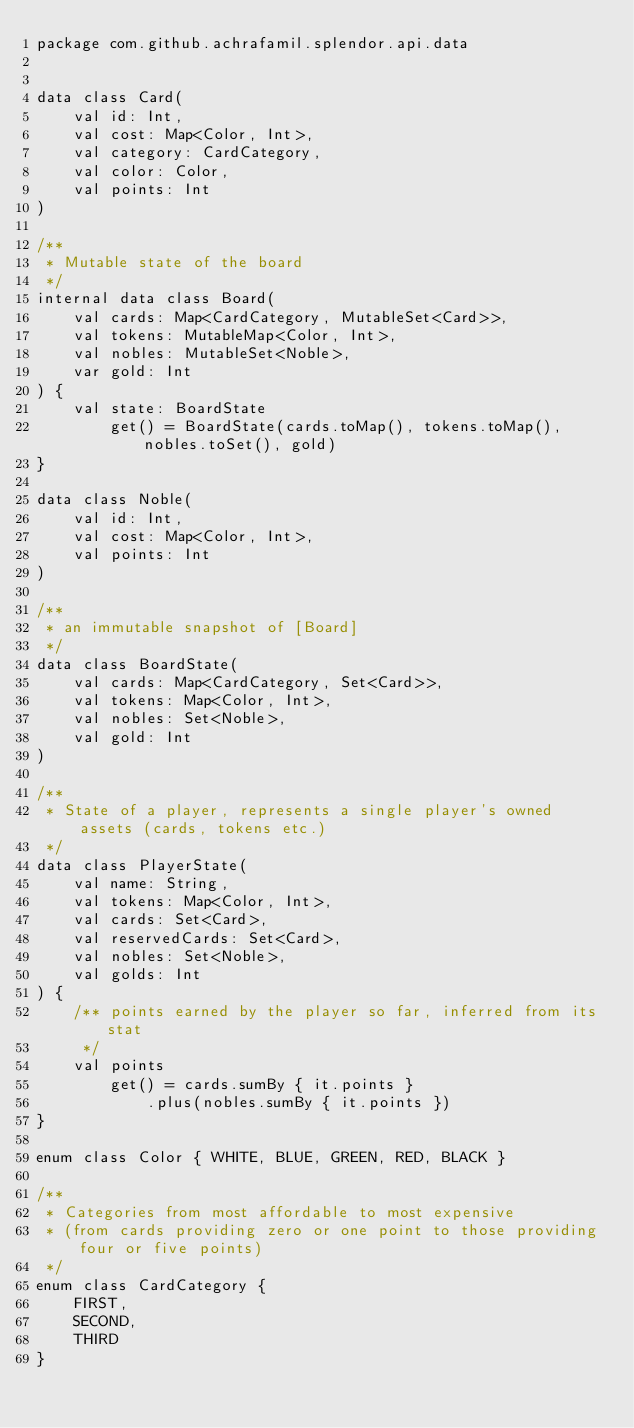Convert code to text. <code><loc_0><loc_0><loc_500><loc_500><_Kotlin_>package com.github.achrafamil.splendor.api.data


data class Card(
    val id: Int,
    val cost: Map<Color, Int>,
    val category: CardCategory,
    val color: Color,
    val points: Int
)

/**
 * Mutable state of the board
 */
internal data class Board(
    val cards: Map<CardCategory, MutableSet<Card>>,
    val tokens: MutableMap<Color, Int>,
    val nobles: MutableSet<Noble>,
    var gold: Int
) {
    val state: BoardState
        get() = BoardState(cards.toMap(), tokens.toMap(), nobles.toSet(), gold)
}

data class Noble(
    val id: Int,
    val cost: Map<Color, Int>,
    val points: Int
)

/**
 * an immutable snapshot of [Board]
 */
data class BoardState(
    val cards: Map<CardCategory, Set<Card>>,
    val tokens: Map<Color, Int>,
    val nobles: Set<Noble>,
    val gold: Int
)

/**
 * State of a player, represents a single player's owned assets (cards, tokens etc.)
 */
data class PlayerState(
    val name: String,
    val tokens: Map<Color, Int>,
    val cards: Set<Card>,
    val reservedCards: Set<Card>,
    val nobles: Set<Noble>,
    val golds: Int
) {
    /** points earned by the player so far, inferred from its stat
     */
    val points
        get() = cards.sumBy { it.points }
            .plus(nobles.sumBy { it.points })
}

enum class Color { WHITE, BLUE, GREEN, RED, BLACK }

/**
 * Categories from most affordable to most expensive
 * (from cards providing zero or one point to those providing four or five points)
 */
enum class CardCategory {
    FIRST,
    SECOND,
    THIRD
}
</code> 